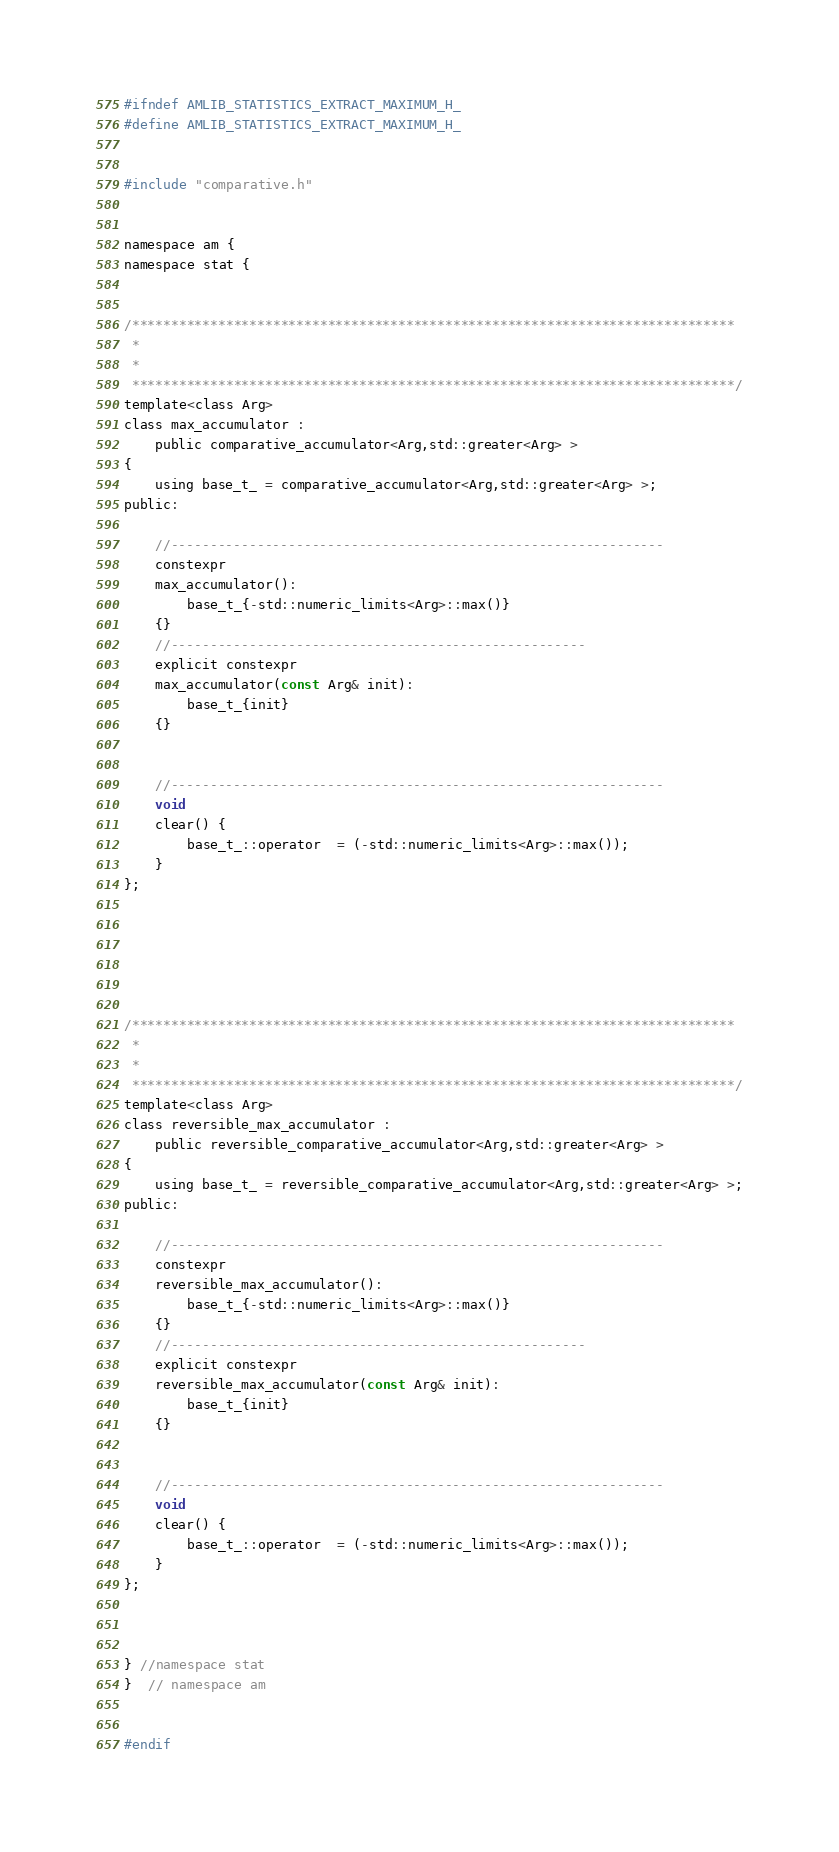<code> <loc_0><loc_0><loc_500><loc_500><_C_>#ifndef AMLIB_STATISTICS_EXTRACT_MAXIMUM_H_
#define AMLIB_STATISTICS_EXTRACT_MAXIMUM_H_


#include "comparative.h"


namespace am {
namespace stat {


/*****************************************************************************
 *
 *
 *****************************************************************************/
template<class Arg>
class max_accumulator :
    public comparative_accumulator<Arg,std::greater<Arg> >
{
    using base_t_ = comparative_accumulator<Arg,std::greater<Arg> >;
public:

    //---------------------------------------------------------------
    constexpr
    max_accumulator():
        base_t_{-std::numeric_limits<Arg>::max()}
    {}
    //-----------------------------------------------------
    explicit constexpr
    max_accumulator(const Arg& init):
        base_t_{init}
    {}


    //---------------------------------------------------------------
    void
    clear() {
        base_t_::operator  = (-std::numeric_limits<Arg>::max());
    }
};






/*****************************************************************************
 *
 *
 *****************************************************************************/
template<class Arg>
class reversible_max_accumulator :
    public reversible_comparative_accumulator<Arg,std::greater<Arg> >
{
    using base_t_ = reversible_comparative_accumulator<Arg,std::greater<Arg> >;
public:

    //---------------------------------------------------------------
    constexpr
    reversible_max_accumulator():
        base_t_{-std::numeric_limits<Arg>::max()}
    {}
    //-----------------------------------------------------
    explicit constexpr
    reversible_max_accumulator(const Arg& init):
        base_t_{init}
    {}


    //---------------------------------------------------------------
    void
    clear() {
        base_t_::operator  = (-std::numeric_limits<Arg>::max());
    }
};



} //namespace stat
}  // namespace am


#endif
</code> 